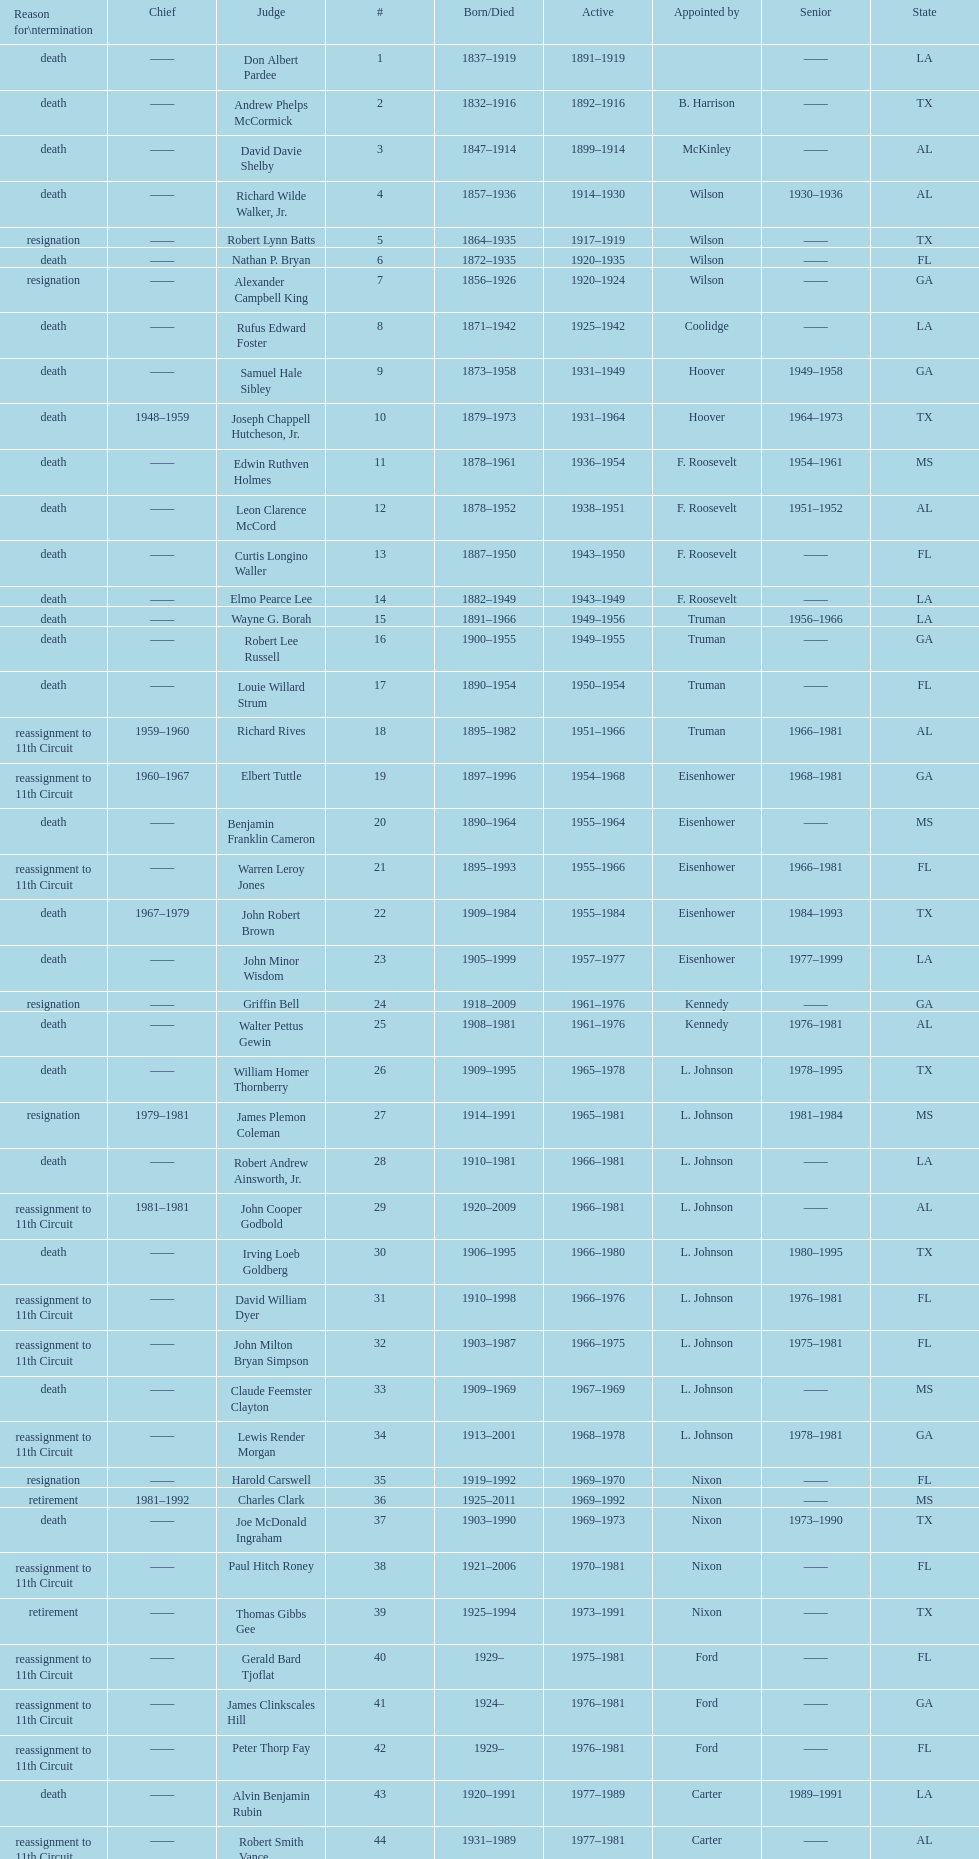Name a state listed at least 4 times. TX. 